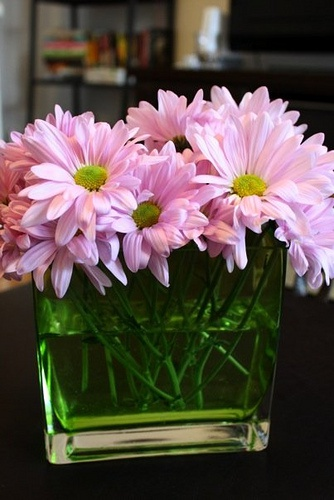Describe the objects in this image and their specific colors. I can see vase in gray, black, darkgreen, and tan tones and book in black, maroon, and gray tones in this image. 